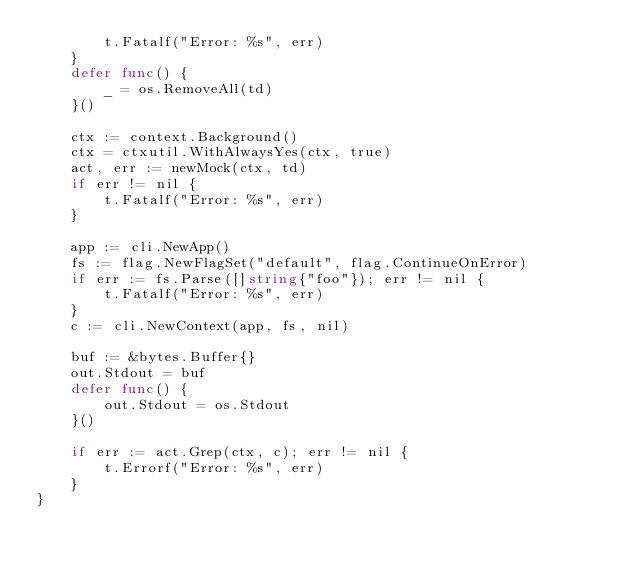<code> <loc_0><loc_0><loc_500><loc_500><_Go_>		t.Fatalf("Error: %s", err)
	}
	defer func() {
		_ = os.RemoveAll(td)
	}()

	ctx := context.Background()
	ctx = ctxutil.WithAlwaysYes(ctx, true)
	act, err := newMock(ctx, td)
	if err != nil {
		t.Fatalf("Error: %s", err)
	}

	app := cli.NewApp()
	fs := flag.NewFlagSet("default", flag.ContinueOnError)
	if err := fs.Parse([]string{"foo"}); err != nil {
		t.Fatalf("Error: %s", err)
	}
	c := cli.NewContext(app, fs, nil)

	buf := &bytes.Buffer{}
	out.Stdout = buf
	defer func() {
		out.Stdout = os.Stdout
	}()

	if err := act.Grep(ctx, c); err != nil {
		t.Errorf("Error: %s", err)
	}
}
</code> 